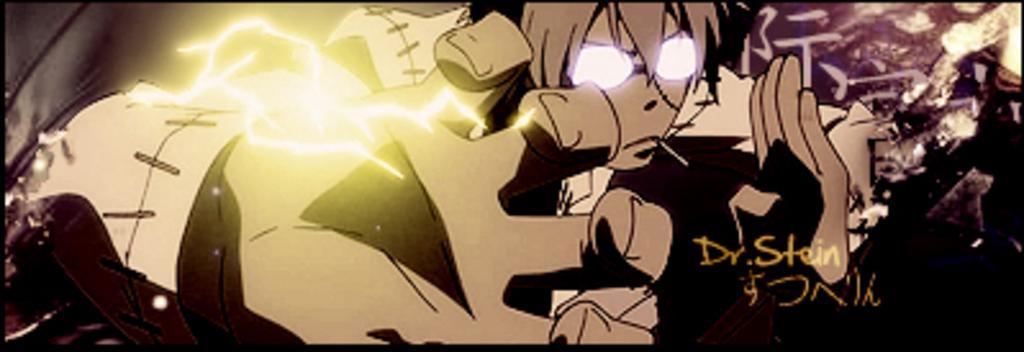Can you describe this image briefly? In this image there is a cartoon picture and there is some text on the right side of the image. 